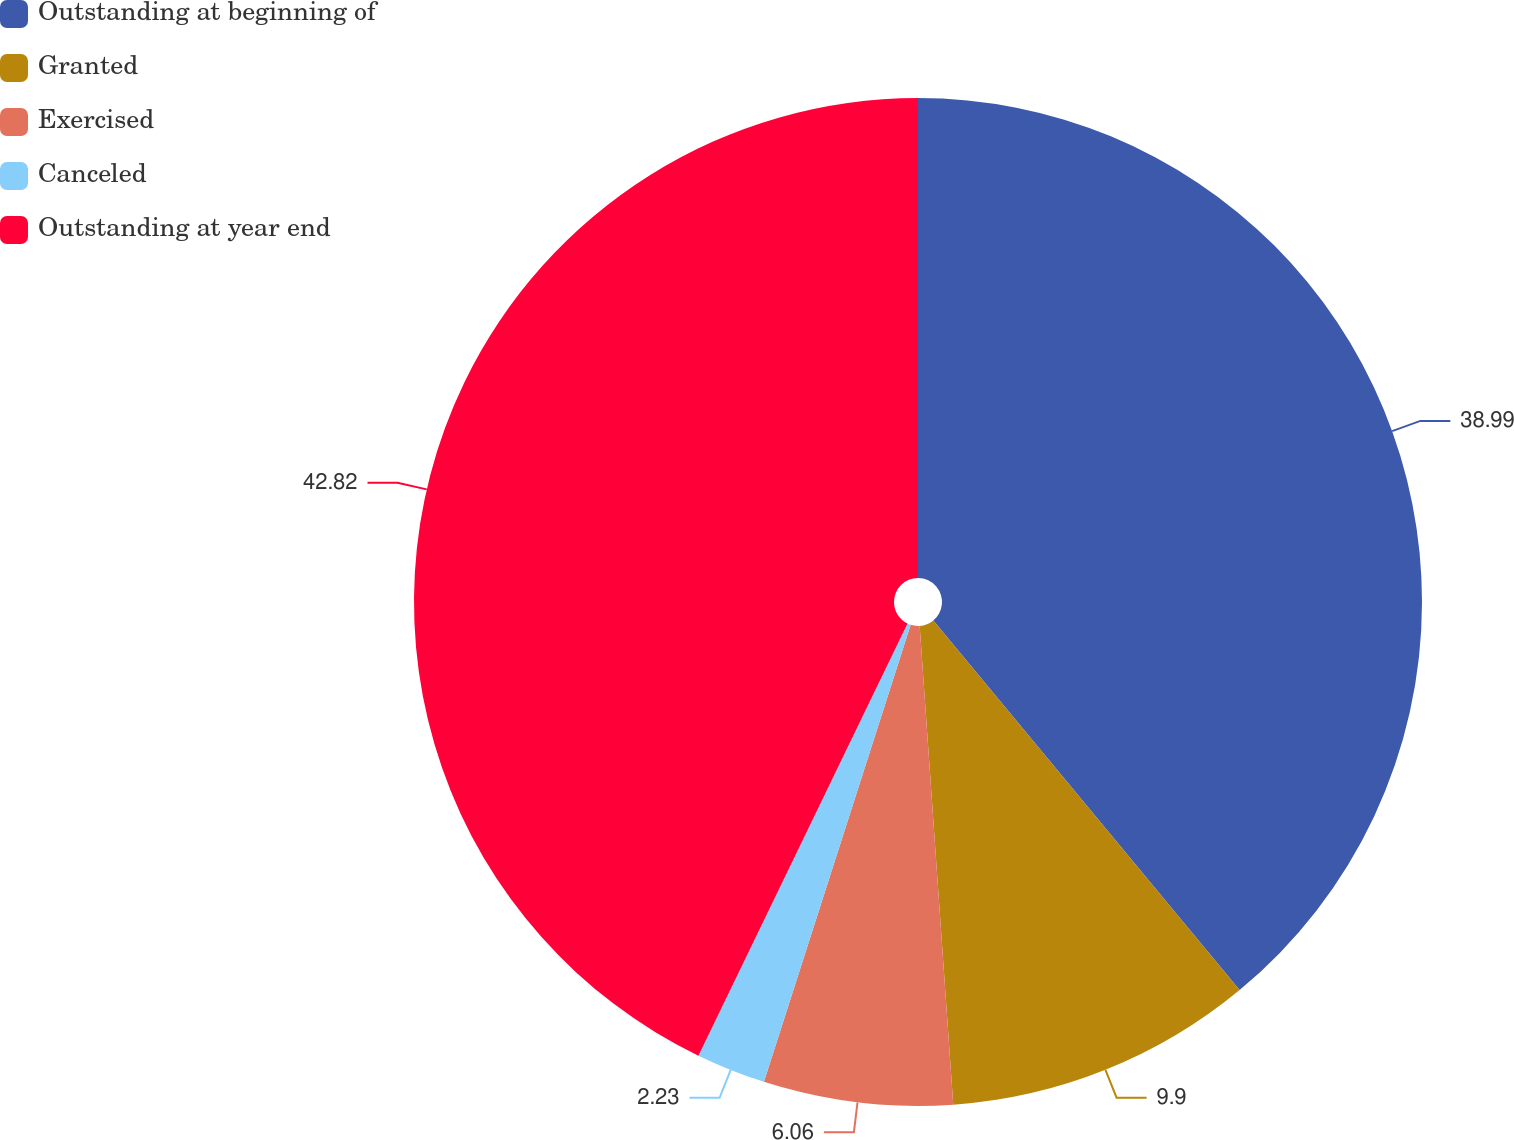Convert chart to OTSL. <chart><loc_0><loc_0><loc_500><loc_500><pie_chart><fcel>Outstanding at beginning of<fcel>Granted<fcel>Exercised<fcel>Canceled<fcel>Outstanding at year end<nl><fcel>38.99%<fcel>9.9%<fcel>6.06%<fcel>2.23%<fcel>42.83%<nl></chart> 